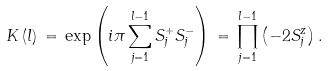Convert formula to latex. <formula><loc_0><loc_0><loc_500><loc_500>K \left ( l \right ) \, = \, \exp \left ( i \pi \sum _ { j = 1 } ^ { l - 1 } S ^ { + } _ { j } S ^ { - } _ { j } \right ) \, = \, \prod _ { j = 1 } ^ { l - 1 } \left ( - 2 S ^ { z } _ { j } \right ) .</formula> 